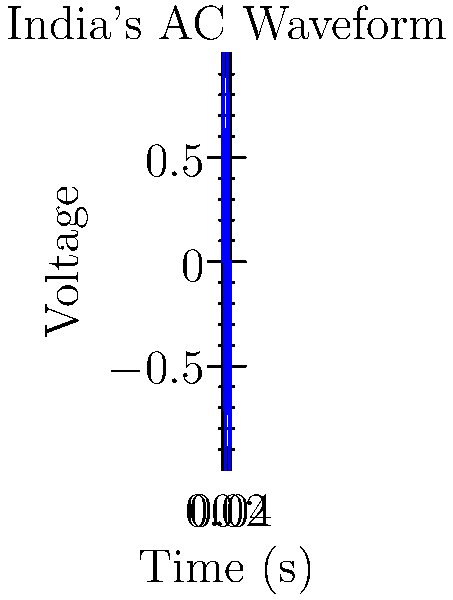Examine the waveform diagram of an AC signal from India's power grid. What is the frequency of this signal, and how does it compare to the standard US power grid frequency? To determine the frequency of the AC signal:

1. Count the number of complete cycles in the given time period:
   The graph shows 2 complete cycles.

2. Identify the time period shown:
   The x-axis goes from 0 to 0.04 seconds.

3. Calculate the frequency using the formula:
   $f = \frac{\text{number of cycles}}{\text{time period}}$
   
   $f = \frac{2}{0.04 \text{ s}} = 50 \text{ Hz}$

4. Compare to US power grid frequency:
   The standard US power grid frequency is 60 Hz.

5. Comparison:
   India's power grid frequency (50 Hz) is lower than the US standard (60 Hz).

This difference in frequency is due to historical and technical reasons in the development of electrical systems in different parts of the world.
Answer: 50 Hz; lower than US (60 Hz) 